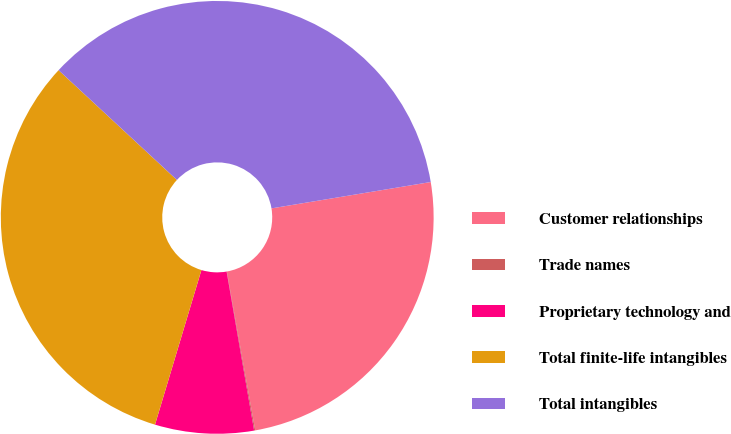Convert chart to OTSL. <chart><loc_0><loc_0><loc_500><loc_500><pie_chart><fcel>Customer relationships<fcel>Trade names<fcel>Proprietary technology and<fcel>Total finite-life intangibles<fcel>Total intangibles<nl><fcel>24.8%<fcel>0.08%<fcel>7.37%<fcel>32.26%<fcel>35.48%<nl></chart> 